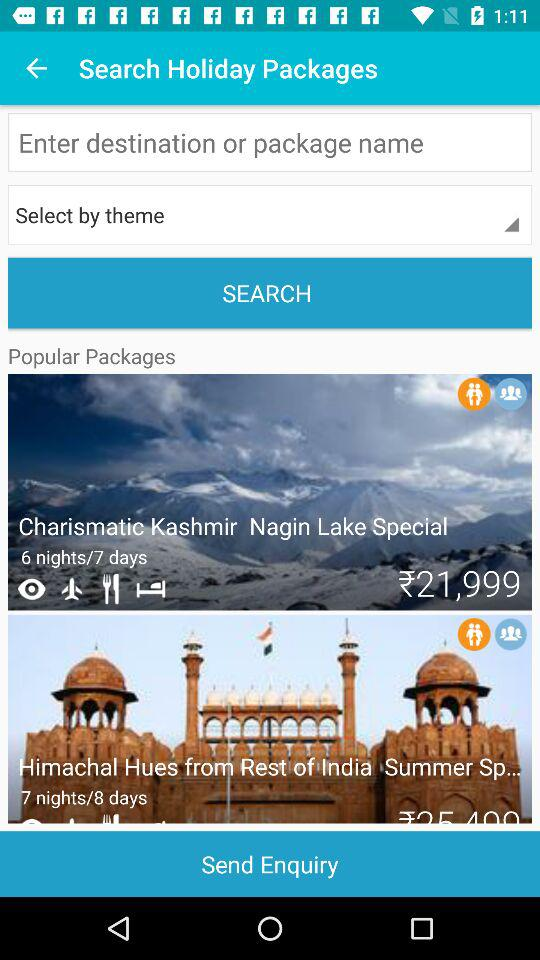How many more nights does the second package have than the first? The second package offers 'Himachal Hues from Rest of India Summer Special,' which lasts for 7 nights/8 days, while the first package 'Charismatic Kashmir - Nagin Lake Special' is for 6 nights/7 days. Therefore, the second package includes one additional night compared to the first, providing an extra day to explore the beauty and attractions of the Himachal region. 